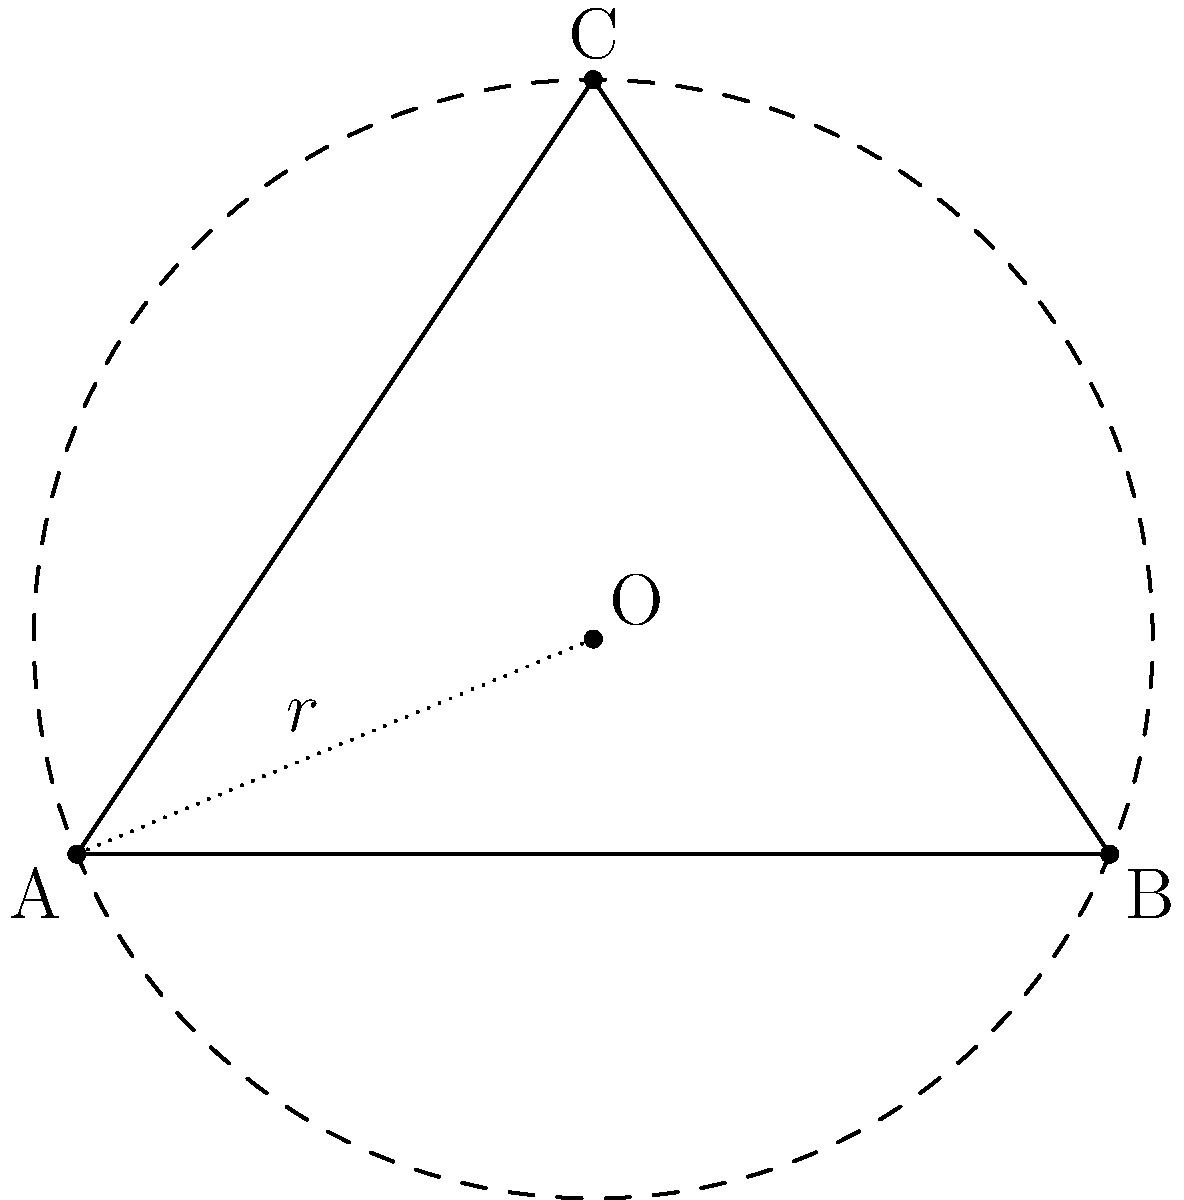In a network topology visualization, three nodes A(0, 0), B(4, 0), and C(2, 3) form a triangle. If these nodes lie on the circumference of a circle representing a wireless network range, determine the center (x, y) and radius r of this circle. How might this information be useful in API design for managing network coverage? To find the center and radius of the circle, we'll follow these steps:

1. Use the perpendicular bisector method:
   - The center of the circle is the point where the perpendicular bisectors of any two chords intersect.
   - We can use the midpoint formula and the equation of a line perpendicular to each side.

2. Find midpoints of AB and AC:
   - Midpoint of AB: $M_{AB} = (\frac{0+4}{2}, \frac{0+0}{2}) = (2, 0)$
   - Midpoint of AC: $M_{AC} = (\frac{0+2}{2}, \frac{0+3}{2}) = (1, 1.5)$

3. Find slopes of AB and AC:
   - Slope of AB: $m_{AB} = \frac{0-0}{4-0} = 0$
   - Slope of AC: $m_{AC} = \frac{3-0}{2-0} = 1.5$

4. Calculate perpendicular slopes:
   - Perpendicular to AB: $m_{\perp AB} = -\frac{1}{m_{AB}} = \text{undefined (vertical line)}$
   - Perpendicular to AC: $m_{\perp AC} = -\frac{1}{m_{AC}} = -\frac{2}{3}$

5. Write equations of perpendicular bisectors:
   - Bisector of AB: $x = 2$
   - Bisector of AC: $y - 1.5 = -\frac{2}{3}(x - 1)$

6. Solve the system of equations to find the center (x, y):
   - $x = 2$
   - $y - 1.5 = -\frac{2}{3}(2 - 1)$
   - $y = 1.5 - \frac{2}{3} = \frac{5}{6}$

   Center: $(2, \frac{5}{6})$

7. Calculate the radius using the distance formula from the center to any of the given points:
   $r = \sqrt{(2-0)^2 + (\frac{5}{6}-0)^2} = \sqrt{4 + \frac{25}{36}} = \sqrt{\frac{169}{36}} = \frac{13}{6}$

This information is useful in API design for managing network coverage as it allows:
- Precise calculation of the network's range
- Optimal placement of access points
- Efficient allocation of network resources
- Implementation of location-based services within the coverage area
Answer: Center: $(2, \frac{5}{6})$, Radius: $\frac{13}{6}$ 